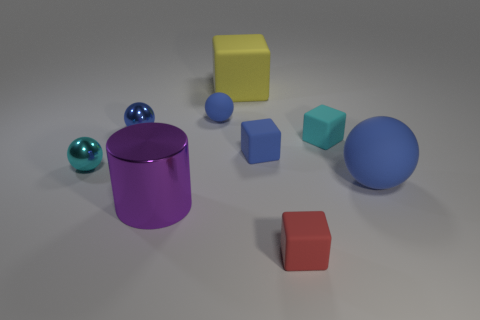There is a large yellow thing behind the blue rubber ball that is right of the small matte ball; what is its shape?
Give a very brief answer. Cube. Is the large matte cube the same color as the cylinder?
Ensure brevity in your answer.  No. What number of blue objects are small cubes or small matte balls?
Offer a terse response. 2. Are there any red rubber cubes behind the large blue sphere?
Provide a succinct answer. No. The purple cylinder is what size?
Give a very brief answer. Large. There is a blue metallic thing that is the same shape as the large blue rubber thing; what size is it?
Your response must be concise. Small. How many large balls are to the left of the small rubber sphere left of the red thing?
Keep it short and to the point. 0. Are the tiny object in front of the big blue matte object and the tiny cyan object that is on the right side of the cyan metal object made of the same material?
Ensure brevity in your answer.  Yes. How many other large objects are the same shape as the red object?
Offer a terse response. 1. What number of matte things are the same color as the large sphere?
Ensure brevity in your answer.  2. 